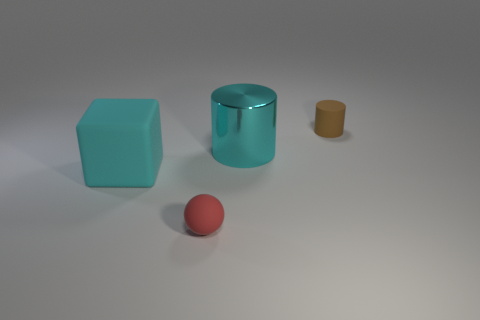Add 4 tiny matte things. How many objects exist? 8 Subtract all balls. How many objects are left? 3 Add 2 large things. How many large things are left? 4 Add 1 big brown matte blocks. How many big brown matte blocks exist? 1 Subtract 0 gray cylinders. How many objects are left? 4 Subtract all small yellow cubes. Subtract all tiny brown cylinders. How many objects are left? 3 